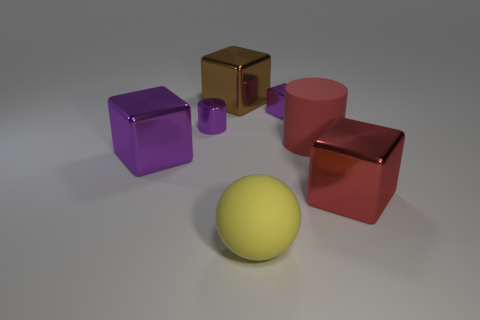Is the size of the purple object that is in front of the purple cylinder the same as the big brown block?
Ensure brevity in your answer.  Yes. The red thing that is the same shape as the big brown object is what size?
Keep it short and to the point. Large. Are there the same number of brown cubes that are in front of the red cylinder and red rubber objects on the right side of the big yellow matte sphere?
Offer a terse response. No. There is a purple shiny block to the left of the big ball; how big is it?
Ensure brevity in your answer.  Large. Do the large cylinder and the ball have the same color?
Provide a short and direct response. No. Is there any other thing that is the same shape as the yellow matte object?
Provide a short and direct response. No. Are there the same number of large purple metal objects behind the brown cube and large purple metal cylinders?
Make the answer very short. Yes. There is a red shiny block; are there any yellow spheres behind it?
Provide a succinct answer. No. There is a large brown metal object; is it the same shape as the big yellow matte object that is in front of the big red metal object?
Your answer should be very brief. No. There is a tiny cylinder that is the same material as the large brown block; what color is it?
Offer a very short reply. Purple. 